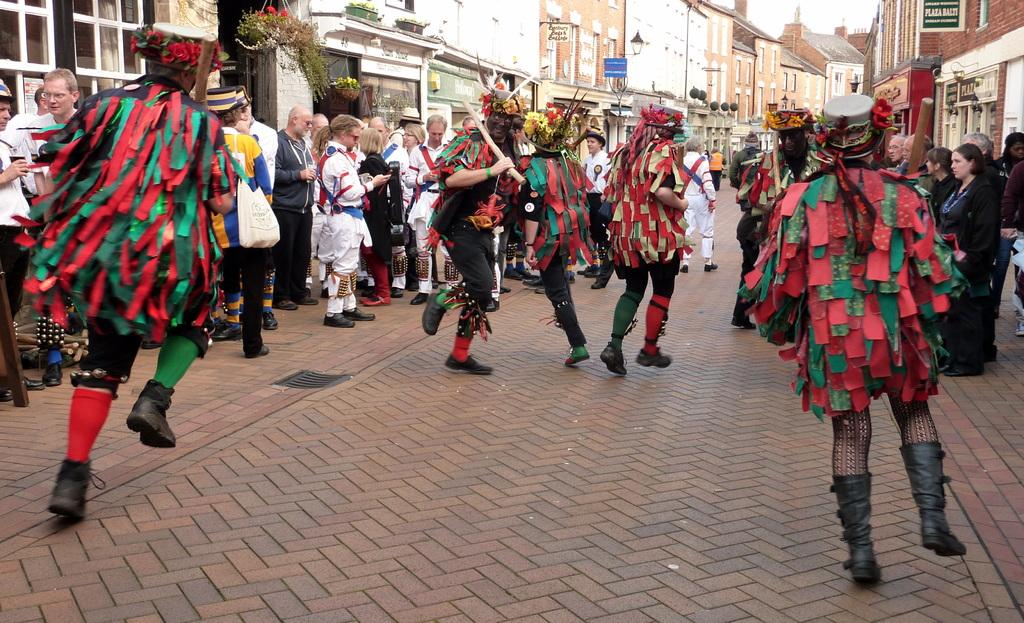What type of structures can be seen in the image? There are buildings in the image. What else is present in the image besides buildings? There are plants and people standing in the image. Can you describe the actions of some people in the image? Some people appear to be dancing in the image. What can be found on the boards with text in the image? The boards with text in the image contain written information. What type of bag is being used by the expert in the image? There is no expert or bag present in the image. 